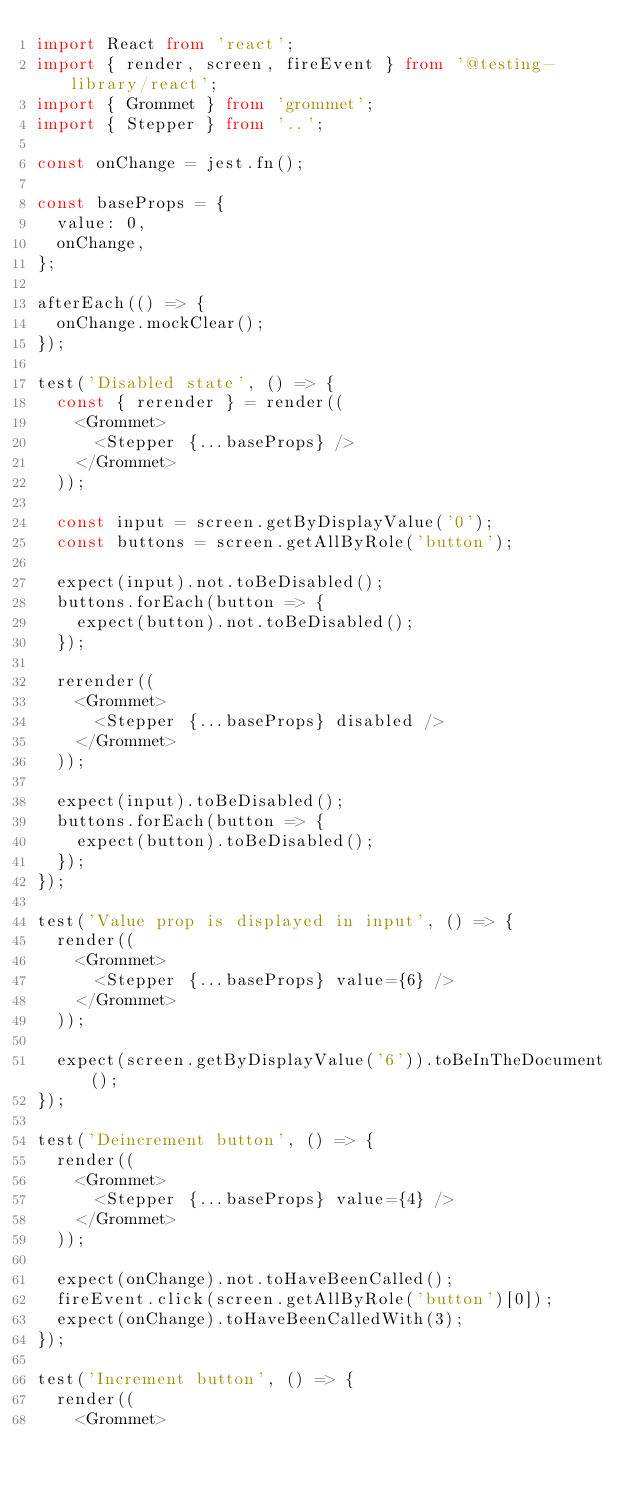<code> <loc_0><loc_0><loc_500><loc_500><_TypeScript_>import React from 'react';
import { render, screen, fireEvent } from '@testing-library/react';
import { Grommet } from 'grommet';
import { Stepper } from '..';

const onChange = jest.fn();

const baseProps = {
	value: 0,
	onChange,
};

afterEach(() => {
	onChange.mockClear();
});

test('Disabled state', () => {
	const { rerender } = render((
		<Grommet>
			<Stepper {...baseProps} />
		</Grommet>
	));

	const input = screen.getByDisplayValue('0');
	const buttons = screen.getAllByRole('button');

	expect(input).not.toBeDisabled();
	buttons.forEach(button => {
		expect(button).not.toBeDisabled();
	});

	rerender((
		<Grommet>
			<Stepper {...baseProps} disabled />
		</Grommet>
	));

	expect(input).toBeDisabled();
	buttons.forEach(button => {
		expect(button).toBeDisabled();
	});
});

test('Value prop is displayed in input', () => {
	render((
		<Grommet>
			<Stepper {...baseProps} value={6} />
		</Grommet>
	));

	expect(screen.getByDisplayValue('6')).toBeInTheDocument();
});

test('Deincrement button', () => {
	render((
		<Grommet>
			<Stepper {...baseProps} value={4} />
		</Grommet>
	));

	expect(onChange).not.toHaveBeenCalled();
	fireEvent.click(screen.getAllByRole('button')[0]);
	expect(onChange).toHaveBeenCalledWith(3);
});

test('Increment button', () => {
	render((
		<Grommet></code> 